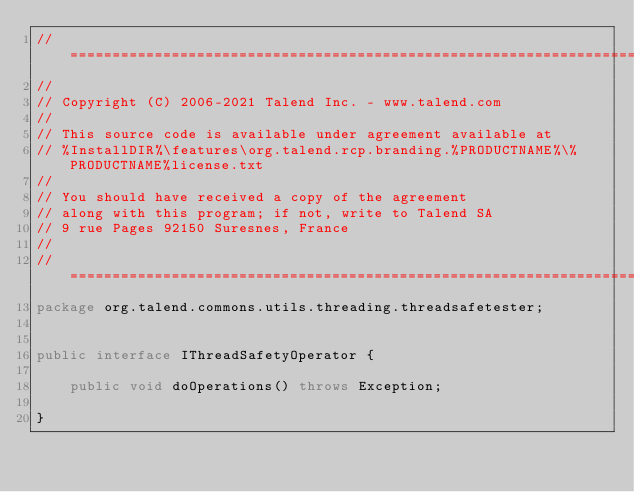Convert code to text. <code><loc_0><loc_0><loc_500><loc_500><_Java_>// ============================================================================
//
// Copyright (C) 2006-2021 Talend Inc. - www.talend.com
//
// This source code is available under agreement available at
// %InstallDIR%\features\org.talend.rcp.branding.%PRODUCTNAME%\%PRODUCTNAME%license.txt
//
// You should have received a copy of the agreement
// along with this program; if not, write to Talend SA
// 9 rue Pages 92150 Suresnes, France
//
// ============================================================================
package org.talend.commons.utils.threading.threadsafetester;


public interface IThreadSafetyOperator {

    public void doOperations() throws Exception;

}
</code> 